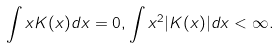<formula> <loc_0><loc_0><loc_500><loc_500>\int x K ( x ) d x = 0 , \int x ^ { 2 } | K ( x ) | d x < \infty .</formula> 